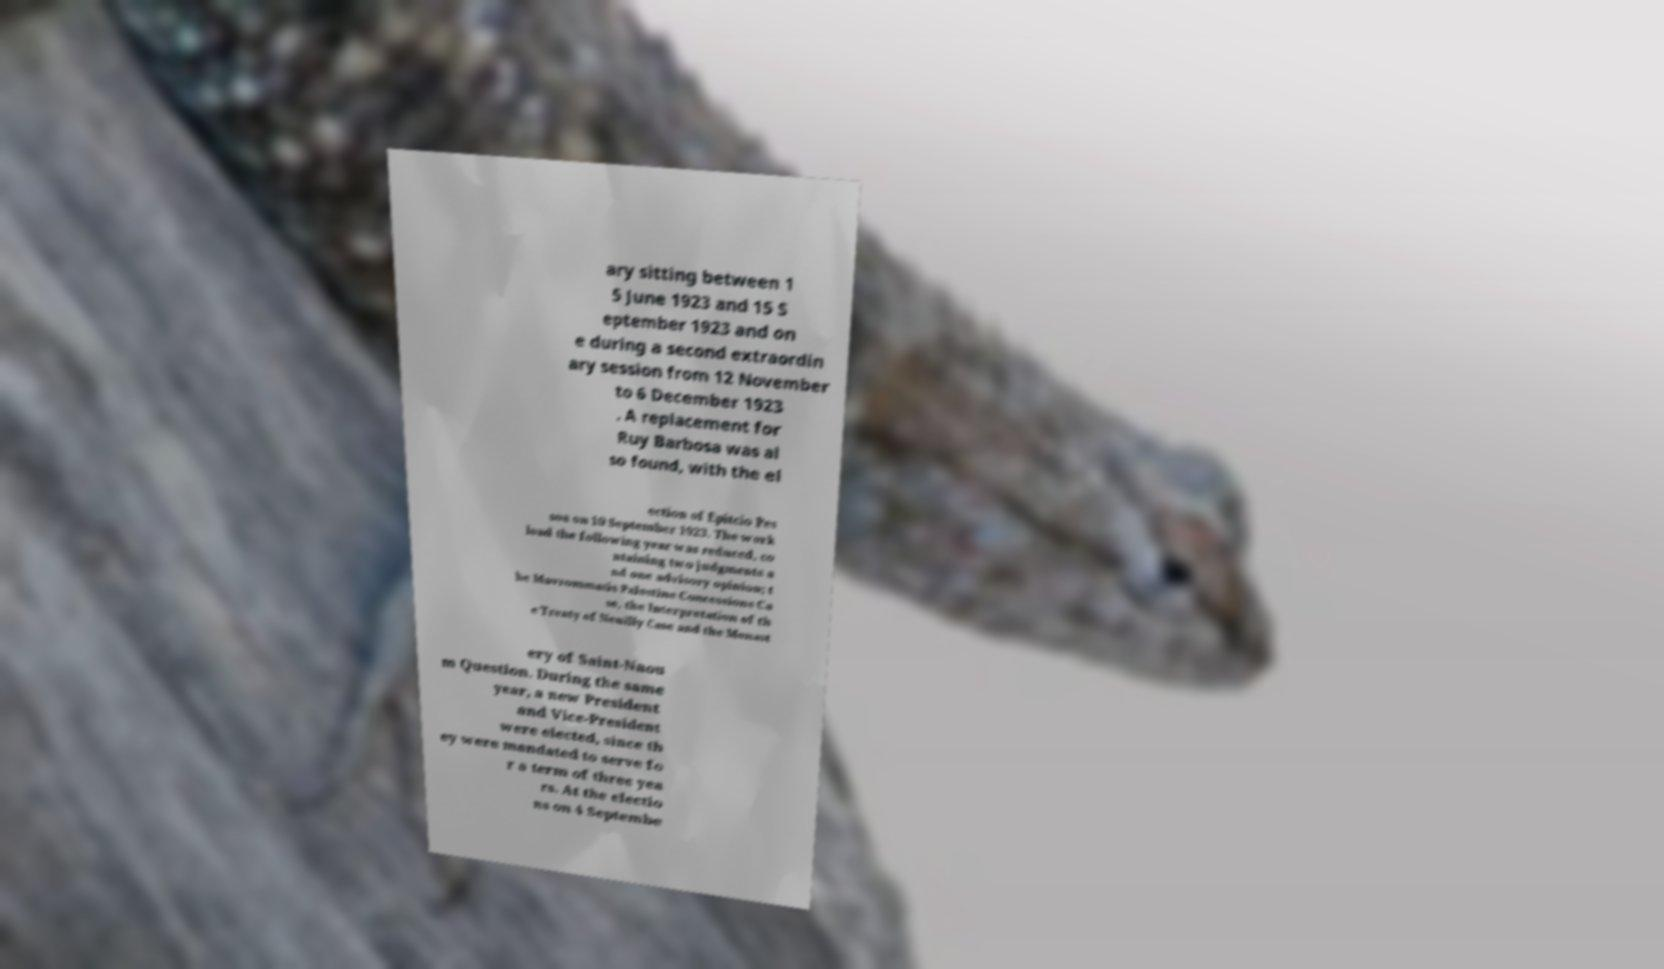I need the written content from this picture converted into text. Can you do that? ary sitting between 1 5 June 1923 and 15 S eptember 1923 and on e during a second extraordin ary session from 12 November to 6 December 1923 . A replacement for Ruy Barbosa was al so found, with the el ection of Epitcio Pes soa on 10 September 1923. The work load the following year was reduced, co ntaining two judgments a nd one advisory opinion; t he Mavrommatis Palestine Concessions Ca se, the Interpretation of th e Treaty of Neuilly Case and the Monast ery of Saint-Naou m Question. During the same year, a new President and Vice-President were elected, since th ey were mandated to serve fo r a term of three yea rs. At the electio ns on 4 Septembe 